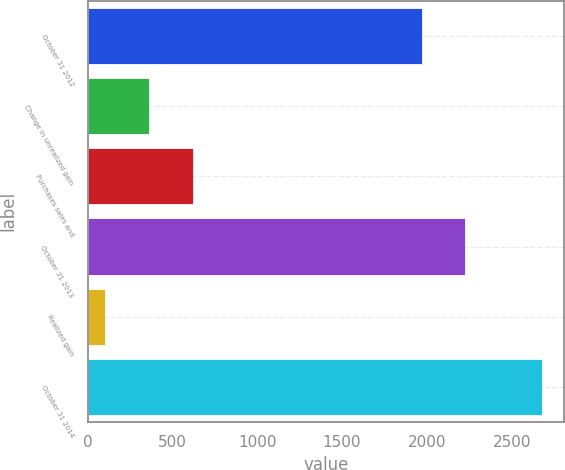Convert chart to OTSL. <chart><loc_0><loc_0><loc_500><loc_500><bar_chart><fcel>October 31 2012<fcel>Change in unrealized gain<fcel>Purchases sales and<fcel>October 31 2013<fcel>Realized gain<fcel>October 31 2014<nl><fcel>1969<fcel>362.2<fcel>619.4<fcel>2226.2<fcel>105<fcel>2677<nl></chart> 